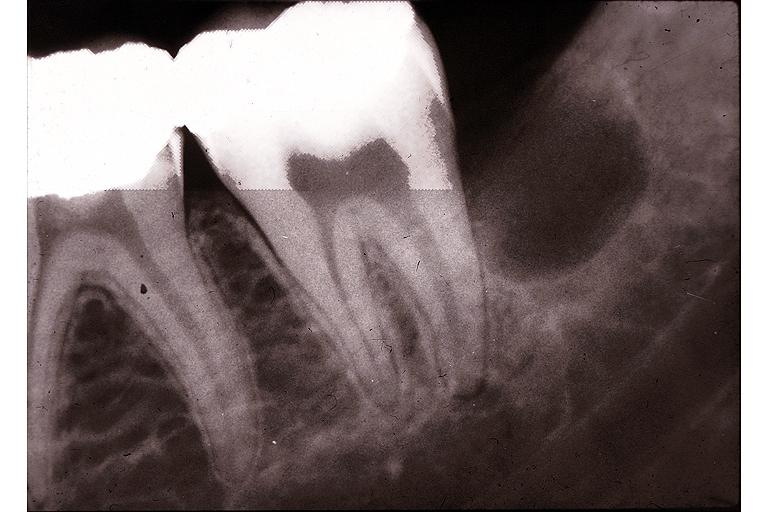does yo show primodial cyst?
Answer the question using a single word or phrase. No 